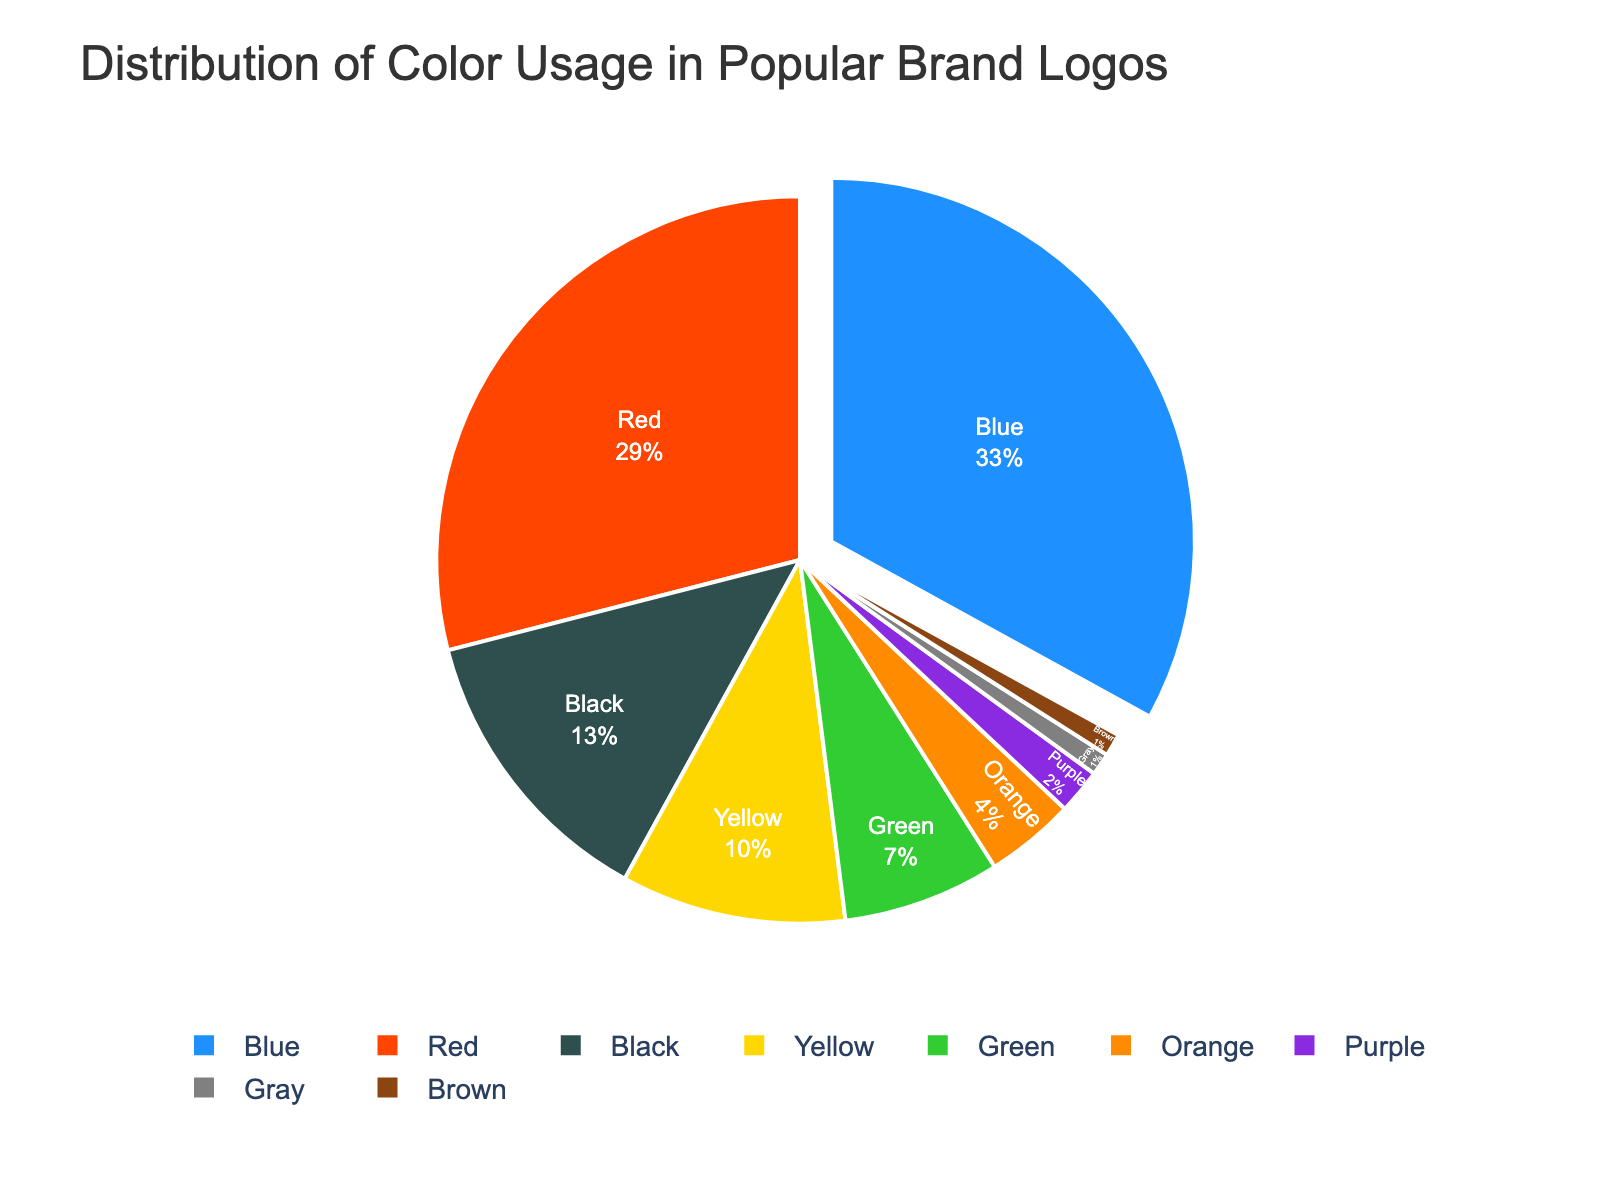What is the most frequently used color in popular brand logos? The most frequently used color is identified by the largest segment in the pie chart. The chart shows that blue has the largest segment.
Answer: Blue Which color is used more: red or green? To determine which color is used more, compare the sizes of the segments for red and green in the pie chart. The red segment is larger than the green segment.
Answer: Red How many colors are used by less than 5% of the brands? Identify segments representing less than 5% of the total. The segments for orange (4%), purple (2%), gray (1%), and brown (1%) all fit this criterion.
Answer: 4 Which color accounts for 10% of the usage in popular brand logos? Locate the color segment labeled as 10% in the pie chart. The yellow segment represents 10%.
Answer: Yellow What is the combined percentage of black and gray usage in the logos? To find the combined percentage, sum the black (13%) and gray (1%) segments. 13% + 1% = 14%.
Answer: 14% Which two colors together make up more than half of the total color usage? Identify the two largest segments and sum their percentages. Blue (33%) and red (29%) combined exceed 50% (33% + 29% = 62%).
Answer: Blue and Red What is the least used color in popular brand logos? The least used color is represented by the smallest segment in the pie chart. Both gray and brown have the smallest segments at 1% each.
Answer: Gray and Brown How much higher is the percentage of blue compared to orange in brand logos? Subtract the percentage of orange (4%) from the percentage of blue (33%). 33% - 4% = 29%.
Answer: 29% Which color segment is pulled out from the pie chart? The pulled-out segment visually stands out from the rest. The blue segment is the one that appears separated.
Answer: Blue 